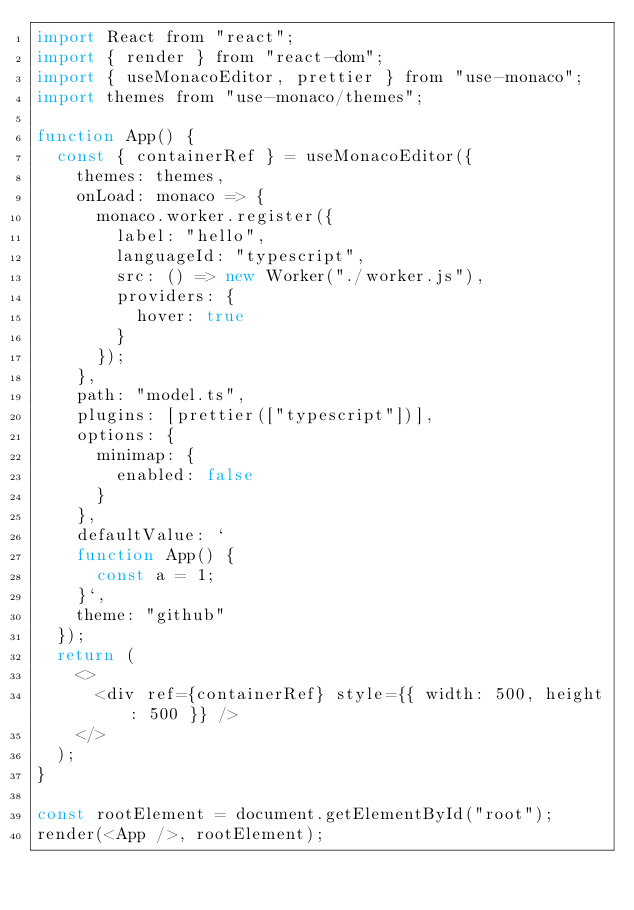<code> <loc_0><loc_0><loc_500><loc_500><_JavaScript_>import React from "react";
import { render } from "react-dom";
import { useMonacoEditor, prettier } from "use-monaco";
import themes from "use-monaco/themes";

function App() {
  const { containerRef } = useMonacoEditor({
    themes: themes,
    onLoad: monaco => {
      monaco.worker.register({
        label: "hello",
        languageId: "typescript",
        src: () => new Worker("./worker.js"),
        providers: {
          hover: true
        }
      });
    },
    path: "model.ts",
    plugins: [prettier(["typescript"])],
    options: {
      minimap: {
        enabled: false
      }
    },
    defaultValue: `
    function App() {
      const a = 1;
    }`,
    theme: "github"
  });
  return (
    <>
      <div ref={containerRef} style={{ width: 500, height: 500 }} />
    </>
  );
}

const rootElement = document.getElementById("root");
render(<App />, rootElement);
</code> 